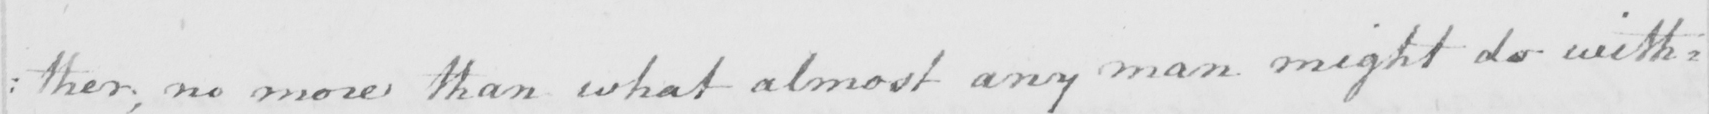What text is written in this handwritten line? : ther , no more than what almost any man might do with= 